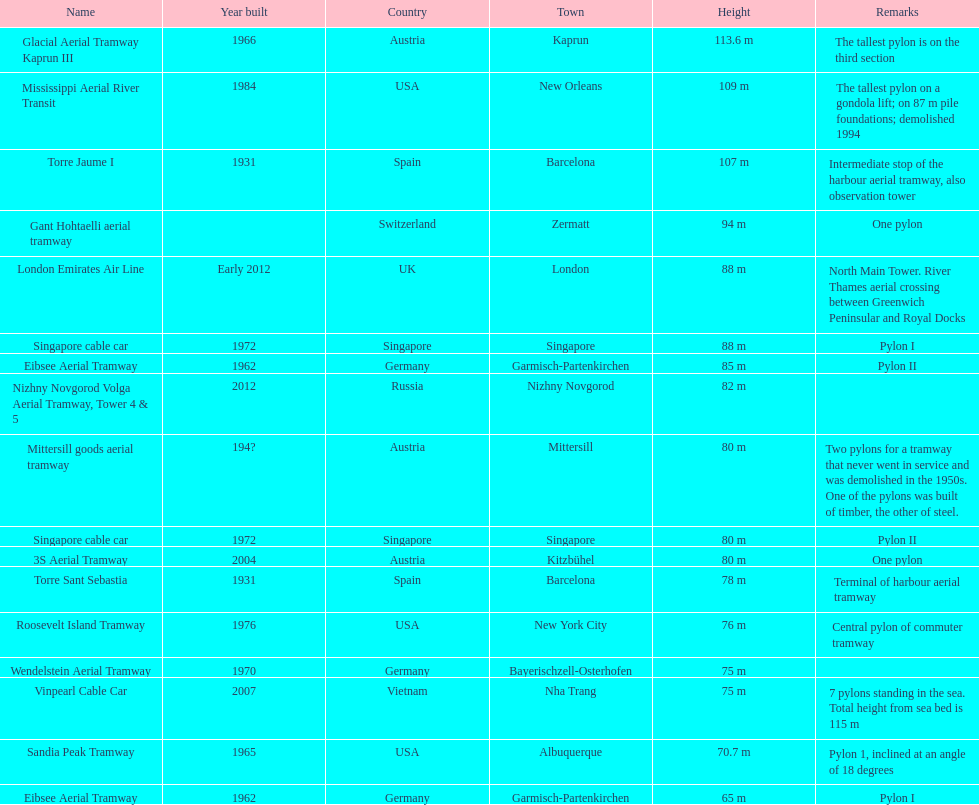What is the aggregate amount of pylons recorded? 17. 